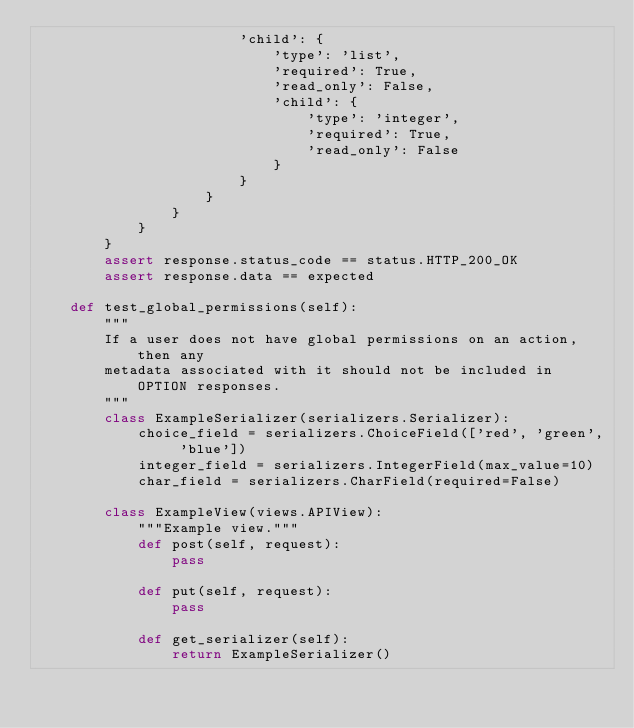<code> <loc_0><loc_0><loc_500><loc_500><_Python_>                        'child': {
                            'type': 'list',
                            'required': True,
                            'read_only': False,
                            'child': {
                                'type': 'integer',
                                'required': True,
                                'read_only': False
                            }
                        }
                    }
                }
            }
        }
        assert response.status_code == status.HTTP_200_OK
        assert response.data == expected

    def test_global_permissions(self):
        """
        If a user does not have global permissions on an action, then any
        metadata associated with it should not be included in OPTION responses.
        """
        class ExampleSerializer(serializers.Serializer):
            choice_field = serializers.ChoiceField(['red', 'green', 'blue'])
            integer_field = serializers.IntegerField(max_value=10)
            char_field = serializers.CharField(required=False)

        class ExampleView(views.APIView):
            """Example view."""
            def post(self, request):
                pass

            def put(self, request):
                pass

            def get_serializer(self):
                return ExampleSerializer()
</code> 